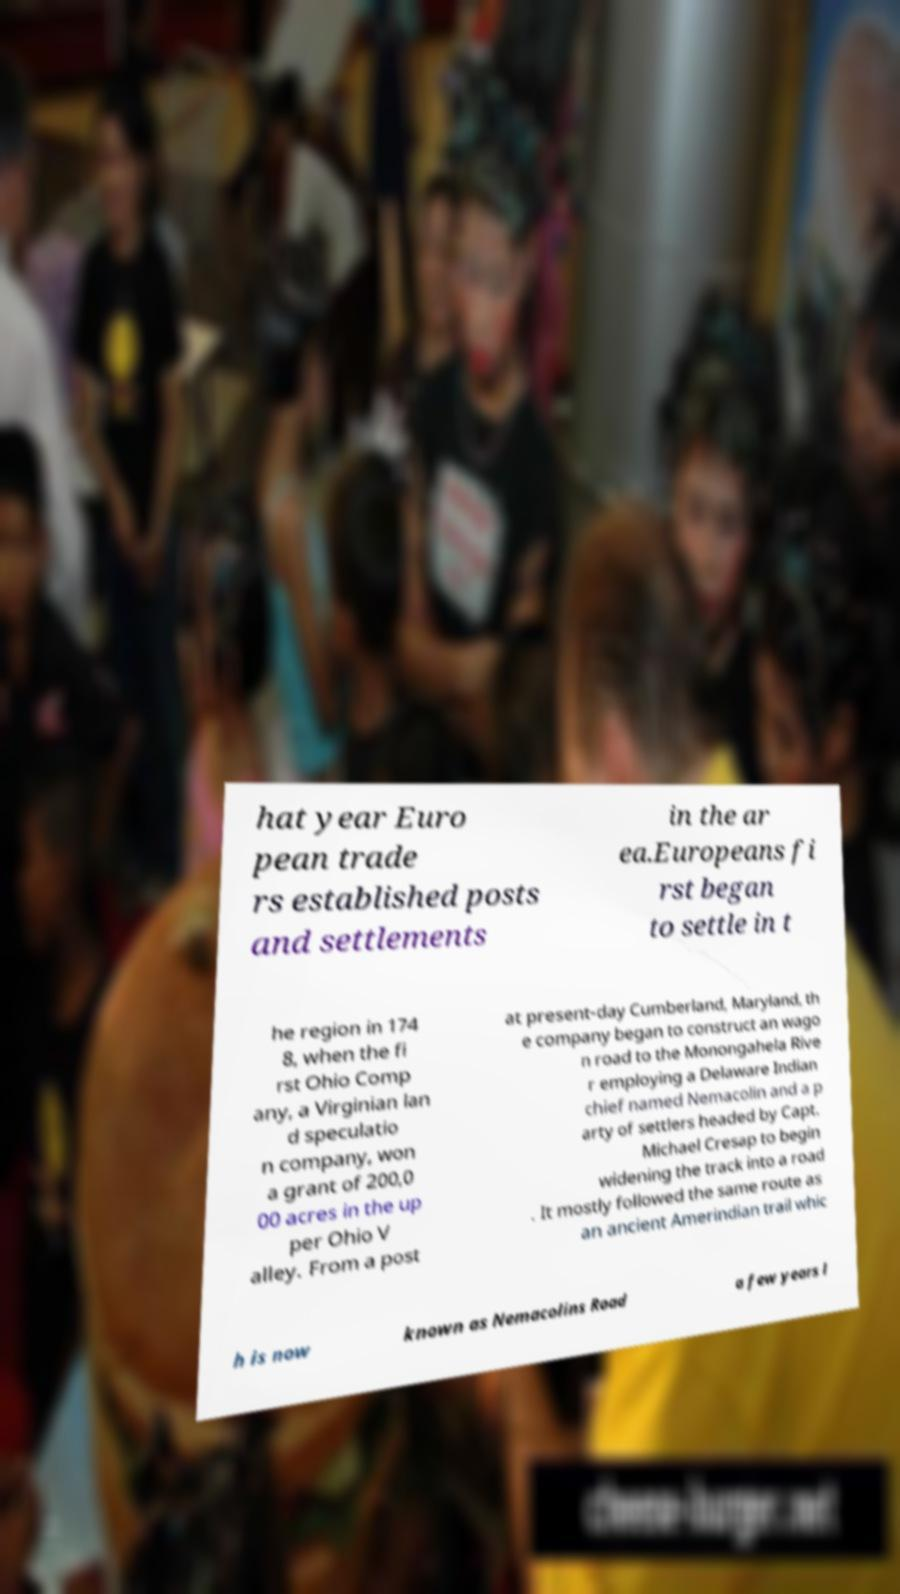There's text embedded in this image that I need extracted. Can you transcribe it verbatim? hat year Euro pean trade rs established posts and settlements in the ar ea.Europeans fi rst began to settle in t he region in 174 8, when the fi rst Ohio Comp any, a Virginian lan d speculatio n company, won a grant of 200,0 00 acres in the up per Ohio V alley. From a post at present-day Cumberland, Maryland, th e company began to construct an wago n road to the Monongahela Rive r employing a Delaware Indian chief named Nemacolin and a p arty of settlers headed by Capt. Michael Cresap to begin widening the track into a road . It mostly followed the same route as an ancient Amerindian trail whic h is now known as Nemacolins Road a few years l 